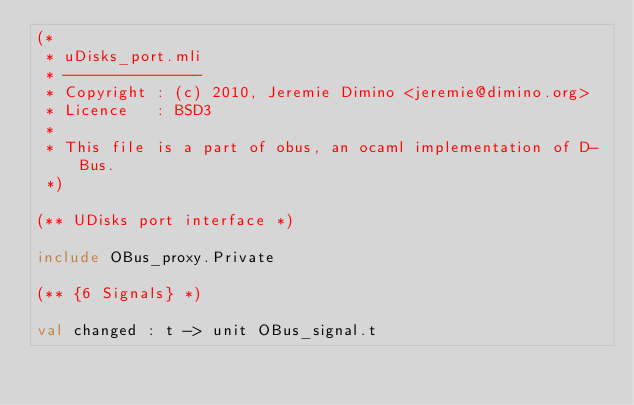Convert code to text. <code><loc_0><loc_0><loc_500><loc_500><_OCaml_>(*
 * uDisks_port.mli
 * ---------------
 * Copyright : (c) 2010, Jeremie Dimino <jeremie@dimino.org>
 * Licence   : BSD3
 *
 * This file is a part of obus, an ocaml implementation of D-Bus.
 *)

(** UDisks port interface *)

include OBus_proxy.Private

(** {6 Signals} *)

val changed : t -> unit OBus_signal.t
</code> 